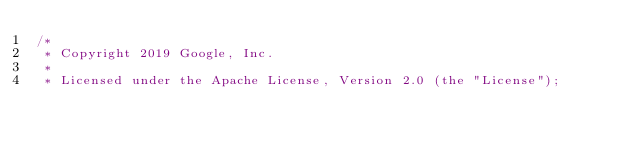<code> <loc_0><loc_0><loc_500><loc_500><_Kotlin_>/*
 * Copyright 2019 Google, Inc.
 *
 * Licensed under the Apache License, Version 2.0 (the "License");</code> 